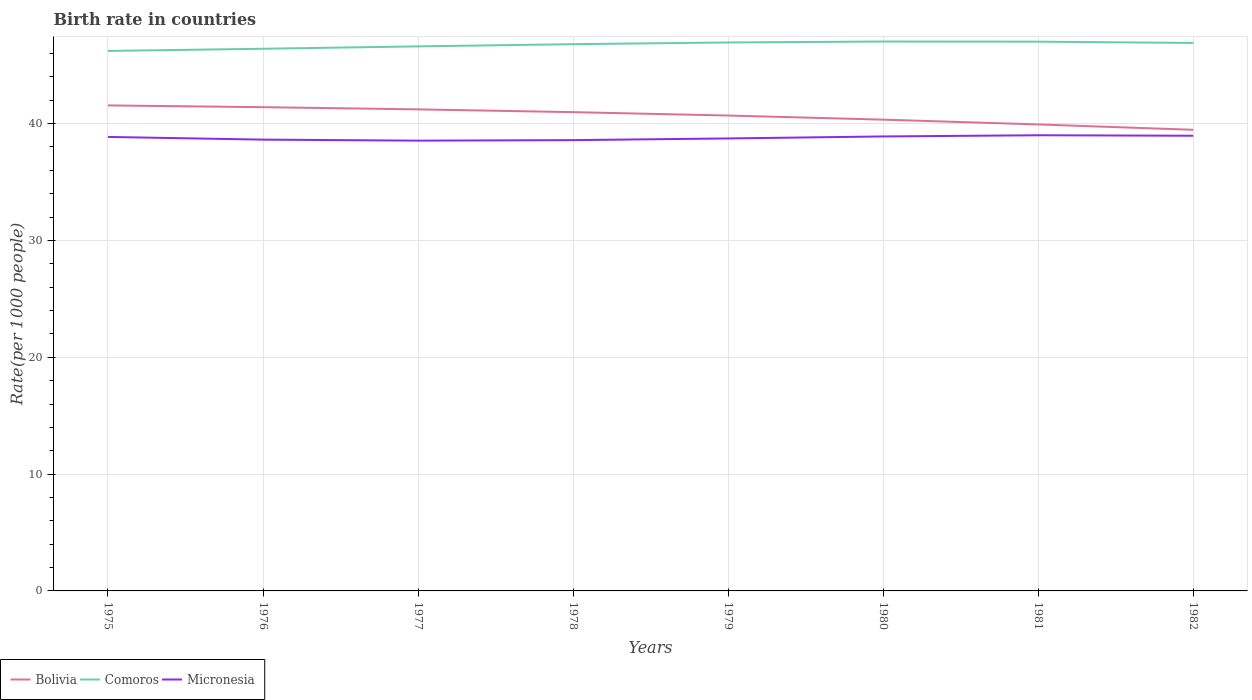Does the line corresponding to Bolivia intersect with the line corresponding to Comoros?
Make the answer very short. No. Is the number of lines equal to the number of legend labels?
Offer a very short reply. Yes. Across all years, what is the maximum birth rate in Micronesia?
Your response must be concise. 38.54. In which year was the birth rate in Bolivia maximum?
Your answer should be very brief. 1982. What is the total birth rate in Bolivia in the graph?
Give a very brief answer. 0.53. What is the difference between the highest and the second highest birth rate in Comoros?
Provide a short and direct response. 0.8. Are the values on the major ticks of Y-axis written in scientific E-notation?
Your answer should be compact. No. Where does the legend appear in the graph?
Offer a terse response. Bottom left. What is the title of the graph?
Offer a terse response. Birth rate in countries. What is the label or title of the X-axis?
Your response must be concise. Years. What is the label or title of the Y-axis?
Keep it short and to the point. Rate(per 1000 people). What is the Rate(per 1000 people) in Bolivia in 1975?
Provide a short and direct response. 41.56. What is the Rate(per 1000 people) in Comoros in 1975?
Provide a succinct answer. 46.22. What is the Rate(per 1000 people) of Micronesia in 1975?
Ensure brevity in your answer.  38.86. What is the Rate(per 1000 people) of Bolivia in 1976?
Make the answer very short. 41.41. What is the Rate(per 1000 people) of Comoros in 1976?
Offer a terse response. 46.41. What is the Rate(per 1000 people) in Micronesia in 1976?
Provide a succinct answer. 38.63. What is the Rate(per 1000 people) of Bolivia in 1977?
Keep it short and to the point. 41.22. What is the Rate(per 1000 people) in Comoros in 1977?
Your response must be concise. 46.61. What is the Rate(per 1000 people) of Micronesia in 1977?
Your answer should be compact. 38.54. What is the Rate(per 1000 people) of Bolivia in 1978?
Keep it short and to the point. 40.98. What is the Rate(per 1000 people) of Comoros in 1978?
Your answer should be very brief. 46.8. What is the Rate(per 1000 people) in Micronesia in 1978?
Make the answer very short. 38.59. What is the Rate(per 1000 people) in Bolivia in 1979?
Your response must be concise. 40.69. What is the Rate(per 1000 people) of Comoros in 1979?
Your answer should be compact. 46.95. What is the Rate(per 1000 people) of Micronesia in 1979?
Make the answer very short. 38.73. What is the Rate(per 1000 people) in Bolivia in 1980?
Provide a short and direct response. 40.34. What is the Rate(per 1000 people) of Comoros in 1980?
Make the answer very short. 47.03. What is the Rate(per 1000 people) in Micronesia in 1980?
Make the answer very short. 38.9. What is the Rate(per 1000 people) in Bolivia in 1981?
Your answer should be very brief. 39.93. What is the Rate(per 1000 people) of Comoros in 1981?
Offer a terse response. 47.02. What is the Rate(per 1000 people) of Micronesia in 1981?
Your answer should be compact. 39.01. What is the Rate(per 1000 people) of Bolivia in 1982?
Offer a very short reply. 39.47. What is the Rate(per 1000 people) in Comoros in 1982?
Your answer should be very brief. 46.91. What is the Rate(per 1000 people) of Micronesia in 1982?
Your response must be concise. 38.96. Across all years, what is the maximum Rate(per 1000 people) of Bolivia?
Make the answer very short. 41.56. Across all years, what is the maximum Rate(per 1000 people) in Comoros?
Make the answer very short. 47.03. Across all years, what is the maximum Rate(per 1000 people) of Micronesia?
Offer a terse response. 39.01. Across all years, what is the minimum Rate(per 1000 people) in Bolivia?
Your answer should be very brief. 39.47. Across all years, what is the minimum Rate(per 1000 people) in Comoros?
Your answer should be compact. 46.22. Across all years, what is the minimum Rate(per 1000 people) of Micronesia?
Your answer should be compact. 38.54. What is the total Rate(per 1000 people) in Bolivia in the graph?
Offer a terse response. 325.61. What is the total Rate(per 1000 people) of Comoros in the graph?
Keep it short and to the point. 373.94. What is the total Rate(per 1000 people) in Micronesia in the graph?
Offer a very short reply. 310.22. What is the difference between the Rate(per 1000 people) of Bolivia in 1975 and that in 1976?
Offer a very short reply. 0.15. What is the difference between the Rate(per 1000 people) of Comoros in 1975 and that in 1976?
Give a very brief answer. -0.19. What is the difference between the Rate(per 1000 people) of Micronesia in 1975 and that in 1976?
Ensure brevity in your answer.  0.23. What is the difference between the Rate(per 1000 people) of Bolivia in 1975 and that in 1977?
Keep it short and to the point. 0.34. What is the difference between the Rate(per 1000 people) of Comoros in 1975 and that in 1977?
Keep it short and to the point. -0.39. What is the difference between the Rate(per 1000 people) in Micronesia in 1975 and that in 1977?
Offer a terse response. 0.32. What is the difference between the Rate(per 1000 people) of Bolivia in 1975 and that in 1978?
Give a very brief answer. 0.58. What is the difference between the Rate(per 1000 people) in Comoros in 1975 and that in 1978?
Make the answer very short. -0.58. What is the difference between the Rate(per 1000 people) of Micronesia in 1975 and that in 1978?
Your answer should be compact. 0.27. What is the difference between the Rate(per 1000 people) in Bolivia in 1975 and that in 1979?
Ensure brevity in your answer.  0.87. What is the difference between the Rate(per 1000 people) in Comoros in 1975 and that in 1979?
Ensure brevity in your answer.  -0.73. What is the difference between the Rate(per 1000 people) in Micronesia in 1975 and that in 1979?
Give a very brief answer. 0.13. What is the difference between the Rate(per 1000 people) in Bolivia in 1975 and that in 1980?
Keep it short and to the point. 1.22. What is the difference between the Rate(per 1000 people) of Comoros in 1975 and that in 1980?
Provide a short and direct response. -0.81. What is the difference between the Rate(per 1000 people) in Micronesia in 1975 and that in 1980?
Provide a succinct answer. -0.04. What is the difference between the Rate(per 1000 people) of Bolivia in 1975 and that in 1981?
Ensure brevity in your answer.  1.63. What is the difference between the Rate(per 1000 people) of Comoros in 1975 and that in 1981?
Provide a short and direct response. -0.79. What is the difference between the Rate(per 1000 people) in Micronesia in 1975 and that in 1981?
Provide a short and direct response. -0.14. What is the difference between the Rate(per 1000 people) in Bolivia in 1975 and that in 1982?
Keep it short and to the point. 2.09. What is the difference between the Rate(per 1000 people) in Comoros in 1975 and that in 1982?
Your response must be concise. -0.68. What is the difference between the Rate(per 1000 people) in Micronesia in 1975 and that in 1982?
Give a very brief answer. -0.1. What is the difference between the Rate(per 1000 people) of Bolivia in 1976 and that in 1977?
Provide a short and direct response. 0.19. What is the difference between the Rate(per 1000 people) in Comoros in 1976 and that in 1977?
Make the answer very short. -0.2. What is the difference between the Rate(per 1000 people) in Micronesia in 1976 and that in 1977?
Your answer should be very brief. 0.09. What is the difference between the Rate(per 1000 people) of Bolivia in 1976 and that in 1978?
Offer a very short reply. 0.42. What is the difference between the Rate(per 1000 people) in Comoros in 1976 and that in 1978?
Your answer should be very brief. -0.39. What is the difference between the Rate(per 1000 people) of Micronesia in 1976 and that in 1978?
Your answer should be compact. 0.04. What is the difference between the Rate(per 1000 people) of Bolivia in 1976 and that in 1979?
Your response must be concise. 0.72. What is the difference between the Rate(per 1000 people) in Comoros in 1976 and that in 1979?
Your response must be concise. -0.54. What is the difference between the Rate(per 1000 people) of Micronesia in 1976 and that in 1979?
Give a very brief answer. -0.1. What is the difference between the Rate(per 1000 people) in Bolivia in 1976 and that in 1980?
Provide a short and direct response. 1.07. What is the difference between the Rate(per 1000 people) in Comoros in 1976 and that in 1980?
Offer a very short reply. -0.62. What is the difference between the Rate(per 1000 people) in Micronesia in 1976 and that in 1980?
Your answer should be very brief. -0.27. What is the difference between the Rate(per 1000 people) in Bolivia in 1976 and that in 1981?
Offer a terse response. 1.48. What is the difference between the Rate(per 1000 people) of Comoros in 1976 and that in 1981?
Offer a very short reply. -0.61. What is the difference between the Rate(per 1000 people) of Micronesia in 1976 and that in 1981?
Offer a terse response. -0.38. What is the difference between the Rate(per 1000 people) of Bolivia in 1976 and that in 1982?
Your response must be concise. 1.94. What is the difference between the Rate(per 1000 people) of Comoros in 1976 and that in 1982?
Keep it short and to the point. -0.5. What is the difference between the Rate(per 1000 people) in Micronesia in 1976 and that in 1982?
Offer a very short reply. -0.33. What is the difference between the Rate(per 1000 people) of Bolivia in 1977 and that in 1978?
Offer a terse response. 0.24. What is the difference between the Rate(per 1000 people) in Comoros in 1977 and that in 1978?
Your response must be concise. -0.19. What is the difference between the Rate(per 1000 people) in Micronesia in 1977 and that in 1978?
Provide a succinct answer. -0.04. What is the difference between the Rate(per 1000 people) of Bolivia in 1977 and that in 1979?
Make the answer very short. 0.53. What is the difference between the Rate(per 1000 people) in Comoros in 1977 and that in 1979?
Ensure brevity in your answer.  -0.34. What is the difference between the Rate(per 1000 people) of Micronesia in 1977 and that in 1979?
Your answer should be compact. -0.19. What is the difference between the Rate(per 1000 people) of Bolivia in 1977 and that in 1980?
Provide a succinct answer. 0.88. What is the difference between the Rate(per 1000 people) of Comoros in 1977 and that in 1980?
Provide a short and direct response. -0.41. What is the difference between the Rate(per 1000 people) in Micronesia in 1977 and that in 1980?
Your response must be concise. -0.36. What is the difference between the Rate(per 1000 people) in Bolivia in 1977 and that in 1981?
Make the answer very short. 1.29. What is the difference between the Rate(per 1000 people) in Comoros in 1977 and that in 1981?
Your answer should be compact. -0.4. What is the difference between the Rate(per 1000 people) of Micronesia in 1977 and that in 1981?
Offer a terse response. -0.46. What is the difference between the Rate(per 1000 people) in Bolivia in 1977 and that in 1982?
Provide a short and direct response. 1.75. What is the difference between the Rate(per 1000 people) of Comoros in 1977 and that in 1982?
Your response must be concise. -0.29. What is the difference between the Rate(per 1000 people) in Micronesia in 1977 and that in 1982?
Provide a succinct answer. -0.42. What is the difference between the Rate(per 1000 people) of Bolivia in 1978 and that in 1979?
Give a very brief answer. 0.29. What is the difference between the Rate(per 1000 people) of Comoros in 1978 and that in 1979?
Offer a very short reply. -0.15. What is the difference between the Rate(per 1000 people) in Micronesia in 1978 and that in 1979?
Your answer should be very brief. -0.14. What is the difference between the Rate(per 1000 people) of Bolivia in 1978 and that in 1980?
Give a very brief answer. 0.64. What is the difference between the Rate(per 1000 people) of Comoros in 1978 and that in 1980?
Provide a succinct answer. -0.23. What is the difference between the Rate(per 1000 people) of Micronesia in 1978 and that in 1980?
Provide a short and direct response. -0.31. What is the difference between the Rate(per 1000 people) in Bolivia in 1978 and that in 1981?
Make the answer very short. 1.05. What is the difference between the Rate(per 1000 people) in Comoros in 1978 and that in 1981?
Give a very brief answer. -0.21. What is the difference between the Rate(per 1000 people) of Micronesia in 1978 and that in 1981?
Keep it short and to the point. -0.42. What is the difference between the Rate(per 1000 people) of Bolivia in 1978 and that in 1982?
Your answer should be compact. 1.51. What is the difference between the Rate(per 1000 people) in Comoros in 1978 and that in 1982?
Your response must be concise. -0.11. What is the difference between the Rate(per 1000 people) of Micronesia in 1978 and that in 1982?
Your answer should be compact. -0.38. What is the difference between the Rate(per 1000 people) in Bolivia in 1979 and that in 1980?
Your answer should be compact. 0.35. What is the difference between the Rate(per 1000 people) in Comoros in 1979 and that in 1980?
Offer a terse response. -0.08. What is the difference between the Rate(per 1000 people) in Micronesia in 1979 and that in 1980?
Give a very brief answer. -0.17. What is the difference between the Rate(per 1000 people) of Bolivia in 1979 and that in 1981?
Keep it short and to the point. 0.76. What is the difference between the Rate(per 1000 people) of Comoros in 1979 and that in 1981?
Provide a succinct answer. -0.07. What is the difference between the Rate(per 1000 people) of Micronesia in 1979 and that in 1981?
Ensure brevity in your answer.  -0.27. What is the difference between the Rate(per 1000 people) in Bolivia in 1979 and that in 1982?
Your answer should be compact. 1.22. What is the difference between the Rate(per 1000 people) in Comoros in 1979 and that in 1982?
Ensure brevity in your answer.  0.04. What is the difference between the Rate(per 1000 people) of Micronesia in 1979 and that in 1982?
Provide a short and direct response. -0.23. What is the difference between the Rate(per 1000 people) of Bolivia in 1980 and that in 1981?
Your response must be concise. 0.41. What is the difference between the Rate(per 1000 people) of Comoros in 1980 and that in 1981?
Offer a terse response. 0.01. What is the difference between the Rate(per 1000 people) in Micronesia in 1980 and that in 1981?
Your response must be concise. -0.1. What is the difference between the Rate(per 1000 people) of Bolivia in 1980 and that in 1982?
Provide a succinct answer. 0.87. What is the difference between the Rate(per 1000 people) of Comoros in 1980 and that in 1982?
Provide a succinct answer. 0.12. What is the difference between the Rate(per 1000 people) in Micronesia in 1980 and that in 1982?
Ensure brevity in your answer.  -0.06. What is the difference between the Rate(per 1000 people) in Bolivia in 1981 and that in 1982?
Provide a succinct answer. 0.46. What is the difference between the Rate(per 1000 people) of Comoros in 1981 and that in 1982?
Ensure brevity in your answer.  0.11. What is the difference between the Rate(per 1000 people) of Micronesia in 1981 and that in 1982?
Keep it short and to the point. 0.04. What is the difference between the Rate(per 1000 people) of Bolivia in 1975 and the Rate(per 1000 people) of Comoros in 1976?
Your answer should be compact. -4.85. What is the difference between the Rate(per 1000 people) in Bolivia in 1975 and the Rate(per 1000 people) in Micronesia in 1976?
Keep it short and to the point. 2.93. What is the difference between the Rate(per 1000 people) of Comoros in 1975 and the Rate(per 1000 people) of Micronesia in 1976?
Provide a short and direct response. 7.59. What is the difference between the Rate(per 1000 people) in Bolivia in 1975 and the Rate(per 1000 people) in Comoros in 1977?
Offer a terse response. -5.05. What is the difference between the Rate(per 1000 people) in Bolivia in 1975 and the Rate(per 1000 people) in Micronesia in 1977?
Your answer should be compact. 3.02. What is the difference between the Rate(per 1000 people) in Comoros in 1975 and the Rate(per 1000 people) in Micronesia in 1977?
Offer a very short reply. 7.68. What is the difference between the Rate(per 1000 people) in Bolivia in 1975 and the Rate(per 1000 people) in Comoros in 1978?
Your answer should be very brief. -5.24. What is the difference between the Rate(per 1000 people) in Bolivia in 1975 and the Rate(per 1000 people) in Micronesia in 1978?
Give a very brief answer. 2.97. What is the difference between the Rate(per 1000 people) of Comoros in 1975 and the Rate(per 1000 people) of Micronesia in 1978?
Your answer should be very brief. 7.63. What is the difference between the Rate(per 1000 people) in Bolivia in 1975 and the Rate(per 1000 people) in Comoros in 1979?
Your answer should be compact. -5.39. What is the difference between the Rate(per 1000 people) in Bolivia in 1975 and the Rate(per 1000 people) in Micronesia in 1979?
Ensure brevity in your answer.  2.83. What is the difference between the Rate(per 1000 people) of Comoros in 1975 and the Rate(per 1000 people) of Micronesia in 1979?
Make the answer very short. 7.49. What is the difference between the Rate(per 1000 people) of Bolivia in 1975 and the Rate(per 1000 people) of Comoros in 1980?
Make the answer very short. -5.47. What is the difference between the Rate(per 1000 people) in Bolivia in 1975 and the Rate(per 1000 people) in Micronesia in 1980?
Your answer should be very brief. 2.66. What is the difference between the Rate(per 1000 people) of Comoros in 1975 and the Rate(per 1000 people) of Micronesia in 1980?
Provide a succinct answer. 7.32. What is the difference between the Rate(per 1000 people) of Bolivia in 1975 and the Rate(per 1000 people) of Comoros in 1981?
Provide a succinct answer. -5.46. What is the difference between the Rate(per 1000 people) of Bolivia in 1975 and the Rate(per 1000 people) of Micronesia in 1981?
Your answer should be very brief. 2.56. What is the difference between the Rate(per 1000 people) of Comoros in 1975 and the Rate(per 1000 people) of Micronesia in 1981?
Your answer should be very brief. 7.22. What is the difference between the Rate(per 1000 people) in Bolivia in 1975 and the Rate(per 1000 people) in Comoros in 1982?
Offer a very short reply. -5.35. What is the difference between the Rate(per 1000 people) of Bolivia in 1975 and the Rate(per 1000 people) of Micronesia in 1982?
Give a very brief answer. 2.6. What is the difference between the Rate(per 1000 people) in Comoros in 1975 and the Rate(per 1000 people) in Micronesia in 1982?
Provide a succinct answer. 7.26. What is the difference between the Rate(per 1000 people) in Bolivia in 1976 and the Rate(per 1000 people) in Comoros in 1977?
Offer a terse response. -5.2. What is the difference between the Rate(per 1000 people) of Bolivia in 1976 and the Rate(per 1000 people) of Micronesia in 1977?
Your answer should be compact. 2.87. What is the difference between the Rate(per 1000 people) of Comoros in 1976 and the Rate(per 1000 people) of Micronesia in 1977?
Provide a succinct answer. 7.87. What is the difference between the Rate(per 1000 people) in Bolivia in 1976 and the Rate(per 1000 people) in Comoros in 1978?
Keep it short and to the point. -5.39. What is the difference between the Rate(per 1000 people) of Bolivia in 1976 and the Rate(per 1000 people) of Micronesia in 1978?
Your answer should be compact. 2.82. What is the difference between the Rate(per 1000 people) in Comoros in 1976 and the Rate(per 1000 people) in Micronesia in 1978?
Offer a terse response. 7.82. What is the difference between the Rate(per 1000 people) in Bolivia in 1976 and the Rate(per 1000 people) in Comoros in 1979?
Give a very brief answer. -5.54. What is the difference between the Rate(per 1000 people) in Bolivia in 1976 and the Rate(per 1000 people) in Micronesia in 1979?
Your response must be concise. 2.68. What is the difference between the Rate(per 1000 people) of Comoros in 1976 and the Rate(per 1000 people) of Micronesia in 1979?
Keep it short and to the point. 7.68. What is the difference between the Rate(per 1000 people) of Bolivia in 1976 and the Rate(per 1000 people) of Comoros in 1980?
Keep it short and to the point. -5.62. What is the difference between the Rate(per 1000 people) in Bolivia in 1976 and the Rate(per 1000 people) in Micronesia in 1980?
Offer a very short reply. 2.51. What is the difference between the Rate(per 1000 people) of Comoros in 1976 and the Rate(per 1000 people) of Micronesia in 1980?
Offer a terse response. 7.51. What is the difference between the Rate(per 1000 people) in Bolivia in 1976 and the Rate(per 1000 people) in Comoros in 1981?
Offer a very short reply. -5.61. What is the difference between the Rate(per 1000 people) of Bolivia in 1976 and the Rate(per 1000 people) of Micronesia in 1981?
Provide a short and direct response. 2.4. What is the difference between the Rate(per 1000 people) in Comoros in 1976 and the Rate(per 1000 people) in Micronesia in 1981?
Your response must be concise. 7.4. What is the difference between the Rate(per 1000 people) of Bolivia in 1976 and the Rate(per 1000 people) of Comoros in 1982?
Your answer should be very brief. -5.5. What is the difference between the Rate(per 1000 people) in Bolivia in 1976 and the Rate(per 1000 people) in Micronesia in 1982?
Give a very brief answer. 2.44. What is the difference between the Rate(per 1000 people) of Comoros in 1976 and the Rate(per 1000 people) of Micronesia in 1982?
Your response must be concise. 7.45. What is the difference between the Rate(per 1000 people) in Bolivia in 1977 and the Rate(per 1000 people) in Comoros in 1978?
Offer a terse response. -5.58. What is the difference between the Rate(per 1000 people) of Bolivia in 1977 and the Rate(per 1000 people) of Micronesia in 1978?
Your answer should be compact. 2.63. What is the difference between the Rate(per 1000 people) of Comoros in 1977 and the Rate(per 1000 people) of Micronesia in 1978?
Your answer should be compact. 8.02. What is the difference between the Rate(per 1000 people) of Bolivia in 1977 and the Rate(per 1000 people) of Comoros in 1979?
Ensure brevity in your answer.  -5.73. What is the difference between the Rate(per 1000 people) of Bolivia in 1977 and the Rate(per 1000 people) of Micronesia in 1979?
Provide a succinct answer. 2.49. What is the difference between the Rate(per 1000 people) in Comoros in 1977 and the Rate(per 1000 people) in Micronesia in 1979?
Ensure brevity in your answer.  7.88. What is the difference between the Rate(per 1000 people) in Bolivia in 1977 and the Rate(per 1000 people) in Comoros in 1980?
Provide a short and direct response. -5.81. What is the difference between the Rate(per 1000 people) of Bolivia in 1977 and the Rate(per 1000 people) of Micronesia in 1980?
Keep it short and to the point. 2.32. What is the difference between the Rate(per 1000 people) of Comoros in 1977 and the Rate(per 1000 people) of Micronesia in 1980?
Your answer should be very brief. 7.71. What is the difference between the Rate(per 1000 people) in Bolivia in 1977 and the Rate(per 1000 people) in Comoros in 1981?
Your answer should be compact. -5.8. What is the difference between the Rate(per 1000 people) of Bolivia in 1977 and the Rate(per 1000 people) of Micronesia in 1981?
Your response must be concise. 2.21. What is the difference between the Rate(per 1000 people) in Comoros in 1977 and the Rate(per 1000 people) in Micronesia in 1981?
Make the answer very short. 7.61. What is the difference between the Rate(per 1000 people) of Bolivia in 1977 and the Rate(per 1000 people) of Comoros in 1982?
Your answer should be very brief. -5.69. What is the difference between the Rate(per 1000 people) in Bolivia in 1977 and the Rate(per 1000 people) in Micronesia in 1982?
Your answer should be compact. 2.26. What is the difference between the Rate(per 1000 people) in Comoros in 1977 and the Rate(per 1000 people) in Micronesia in 1982?
Your response must be concise. 7.65. What is the difference between the Rate(per 1000 people) in Bolivia in 1978 and the Rate(per 1000 people) in Comoros in 1979?
Offer a terse response. -5.96. What is the difference between the Rate(per 1000 people) of Bolivia in 1978 and the Rate(per 1000 people) of Micronesia in 1979?
Offer a very short reply. 2.25. What is the difference between the Rate(per 1000 people) in Comoros in 1978 and the Rate(per 1000 people) in Micronesia in 1979?
Offer a terse response. 8.07. What is the difference between the Rate(per 1000 people) in Bolivia in 1978 and the Rate(per 1000 people) in Comoros in 1980?
Your answer should be very brief. -6.04. What is the difference between the Rate(per 1000 people) in Bolivia in 1978 and the Rate(per 1000 people) in Micronesia in 1980?
Your answer should be very brief. 2.08. What is the difference between the Rate(per 1000 people) in Comoros in 1978 and the Rate(per 1000 people) in Micronesia in 1980?
Give a very brief answer. 7.9. What is the difference between the Rate(per 1000 people) of Bolivia in 1978 and the Rate(per 1000 people) of Comoros in 1981?
Keep it short and to the point. -6.03. What is the difference between the Rate(per 1000 people) in Bolivia in 1978 and the Rate(per 1000 people) in Micronesia in 1981?
Offer a terse response. 1.98. What is the difference between the Rate(per 1000 people) in Comoros in 1978 and the Rate(per 1000 people) in Micronesia in 1981?
Ensure brevity in your answer.  7.79. What is the difference between the Rate(per 1000 people) of Bolivia in 1978 and the Rate(per 1000 people) of Comoros in 1982?
Your answer should be compact. -5.92. What is the difference between the Rate(per 1000 people) in Bolivia in 1978 and the Rate(per 1000 people) in Micronesia in 1982?
Provide a succinct answer. 2.02. What is the difference between the Rate(per 1000 people) in Comoros in 1978 and the Rate(per 1000 people) in Micronesia in 1982?
Keep it short and to the point. 7.84. What is the difference between the Rate(per 1000 people) of Bolivia in 1979 and the Rate(per 1000 people) of Comoros in 1980?
Your answer should be compact. -6.33. What is the difference between the Rate(per 1000 people) in Bolivia in 1979 and the Rate(per 1000 people) in Micronesia in 1980?
Your answer should be compact. 1.79. What is the difference between the Rate(per 1000 people) of Comoros in 1979 and the Rate(per 1000 people) of Micronesia in 1980?
Offer a very short reply. 8.05. What is the difference between the Rate(per 1000 people) in Bolivia in 1979 and the Rate(per 1000 people) in Comoros in 1981?
Your answer should be very brief. -6.32. What is the difference between the Rate(per 1000 people) of Bolivia in 1979 and the Rate(per 1000 people) of Micronesia in 1981?
Your response must be concise. 1.69. What is the difference between the Rate(per 1000 people) of Comoros in 1979 and the Rate(per 1000 people) of Micronesia in 1981?
Your response must be concise. 7.94. What is the difference between the Rate(per 1000 people) of Bolivia in 1979 and the Rate(per 1000 people) of Comoros in 1982?
Offer a very short reply. -6.21. What is the difference between the Rate(per 1000 people) in Bolivia in 1979 and the Rate(per 1000 people) in Micronesia in 1982?
Make the answer very short. 1.73. What is the difference between the Rate(per 1000 people) in Comoros in 1979 and the Rate(per 1000 people) in Micronesia in 1982?
Provide a succinct answer. 7.99. What is the difference between the Rate(per 1000 people) in Bolivia in 1980 and the Rate(per 1000 people) in Comoros in 1981?
Your response must be concise. -6.67. What is the difference between the Rate(per 1000 people) in Bolivia in 1980 and the Rate(per 1000 people) in Micronesia in 1981?
Your response must be concise. 1.34. What is the difference between the Rate(per 1000 people) of Comoros in 1980 and the Rate(per 1000 people) of Micronesia in 1981?
Offer a terse response. 8.02. What is the difference between the Rate(per 1000 people) of Bolivia in 1980 and the Rate(per 1000 people) of Comoros in 1982?
Make the answer very short. -6.57. What is the difference between the Rate(per 1000 people) of Bolivia in 1980 and the Rate(per 1000 people) of Micronesia in 1982?
Give a very brief answer. 1.38. What is the difference between the Rate(per 1000 people) in Comoros in 1980 and the Rate(per 1000 people) in Micronesia in 1982?
Your response must be concise. 8.06. What is the difference between the Rate(per 1000 people) of Bolivia in 1981 and the Rate(per 1000 people) of Comoros in 1982?
Keep it short and to the point. -6.97. What is the difference between the Rate(per 1000 people) of Bolivia in 1981 and the Rate(per 1000 people) of Micronesia in 1982?
Your answer should be very brief. 0.97. What is the difference between the Rate(per 1000 people) of Comoros in 1981 and the Rate(per 1000 people) of Micronesia in 1982?
Your answer should be compact. 8.05. What is the average Rate(per 1000 people) of Bolivia per year?
Ensure brevity in your answer.  40.7. What is the average Rate(per 1000 people) of Comoros per year?
Ensure brevity in your answer.  46.74. What is the average Rate(per 1000 people) of Micronesia per year?
Keep it short and to the point. 38.78. In the year 1975, what is the difference between the Rate(per 1000 people) in Bolivia and Rate(per 1000 people) in Comoros?
Keep it short and to the point. -4.66. In the year 1975, what is the difference between the Rate(per 1000 people) in Bolivia and Rate(per 1000 people) in Micronesia?
Ensure brevity in your answer.  2.7. In the year 1975, what is the difference between the Rate(per 1000 people) in Comoros and Rate(per 1000 people) in Micronesia?
Offer a terse response. 7.36. In the year 1976, what is the difference between the Rate(per 1000 people) in Bolivia and Rate(per 1000 people) in Comoros?
Provide a short and direct response. -5. In the year 1976, what is the difference between the Rate(per 1000 people) in Bolivia and Rate(per 1000 people) in Micronesia?
Offer a terse response. 2.78. In the year 1976, what is the difference between the Rate(per 1000 people) of Comoros and Rate(per 1000 people) of Micronesia?
Your answer should be very brief. 7.78. In the year 1977, what is the difference between the Rate(per 1000 people) of Bolivia and Rate(per 1000 people) of Comoros?
Ensure brevity in your answer.  -5.39. In the year 1977, what is the difference between the Rate(per 1000 people) in Bolivia and Rate(per 1000 people) in Micronesia?
Make the answer very short. 2.68. In the year 1977, what is the difference between the Rate(per 1000 people) in Comoros and Rate(per 1000 people) in Micronesia?
Provide a succinct answer. 8.07. In the year 1978, what is the difference between the Rate(per 1000 people) in Bolivia and Rate(per 1000 people) in Comoros?
Your response must be concise. -5.82. In the year 1978, what is the difference between the Rate(per 1000 people) in Bolivia and Rate(per 1000 people) in Micronesia?
Provide a succinct answer. 2.4. In the year 1978, what is the difference between the Rate(per 1000 people) of Comoros and Rate(per 1000 people) of Micronesia?
Your response must be concise. 8.21. In the year 1979, what is the difference between the Rate(per 1000 people) of Bolivia and Rate(per 1000 people) of Comoros?
Offer a very short reply. -6.26. In the year 1979, what is the difference between the Rate(per 1000 people) of Bolivia and Rate(per 1000 people) of Micronesia?
Provide a succinct answer. 1.96. In the year 1979, what is the difference between the Rate(per 1000 people) of Comoros and Rate(per 1000 people) of Micronesia?
Ensure brevity in your answer.  8.22. In the year 1980, what is the difference between the Rate(per 1000 people) in Bolivia and Rate(per 1000 people) in Comoros?
Give a very brief answer. -6.69. In the year 1980, what is the difference between the Rate(per 1000 people) in Bolivia and Rate(per 1000 people) in Micronesia?
Provide a succinct answer. 1.44. In the year 1980, what is the difference between the Rate(per 1000 people) in Comoros and Rate(per 1000 people) in Micronesia?
Provide a short and direct response. 8.12. In the year 1981, what is the difference between the Rate(per 1000 people) in Bolivia and Rate(per 1000 people) in Comoros?
Your answer should be very brief. -7.08. In the year 1981, what is the difference between the Rate(per 1000 people) in Bolivia and Rate(per 1000 people) in Micronesia?
Your answer should be very brief. 0.93. In the year 1981, what is the difference between the Rate(per 1000 people) in Comoros and Rate(per 1000 people) in Micronesia?
Ensure brevity in your answer.  8.01. In the year 1982, what is the difference between the Rate(per 1000 people) in Bolivia and Rate(per 1000 people) in Comoros?
Make the answer very short. -7.43. In the year 1982, what is the difference between the Rate(per 1000 people) of Bolivia and Rate(per 1000 people) of Micronesia?
Provide a short and direct response. 0.51. In the year 1982, what is the difference between the Rate(per 1000 people) of Comoros and Rate(per 1000 people) of Micronesia?
Your answer should be compact. 7.94. What is the ratio of the Rate(per 1000 people) in Bolivia in 1975 to that in 1976?
Your answer should be compact. 1. What is the ratio of the Rate(per 1000 people) in Comoros in 1975 to that in 1976?
Offer a terse response. 1. What is the ratio of the Rate(per 1000 people) of Bolivia in 1975 to that in 1977?
Keep it short and to the point. 1.01. What is the ratio of the Rate(per 1000 people) of Micronesia in 1975 to that in 1977?
Provide a short and direct response. 1.01. What is the ratio of the Rate(per 1000 people) in Bolivia in 1975 to that in 1978?
Provide a short and direct response. 1.01. What is the ratio of the Rate(per 1000 people) of Comoros in 1975 to that in 1978?
Make the answer very short. 0.99. What is the ratio of the Rate(per 1000 people) of Micronesia in 1975 to that in 1978?
Your answer should be very brief. 1.01. What is the ratio of the Rate(per 1000 people) in Bolivia in 1975 to that in 1979?
Ensure brevity in your answer.  1.02. What is the ratio of the Rate(per 1000 people) in Comoros in 1975 to that in 1979?
Offer a very short reply. 0.98. What is the ratio of the Rate(per 1000 people) of Micronesia in 1975 to that in 1979?
Offer a terse response. 1. What is the ratio of the Rate(per 1000 people) of Bolivia in 1975 to that in 1980?
Your response must be concise. 1.03. What is the ratio of the Rate(per 1000 people) in Comoros in 1975 to that in 1980?
Keep it short and to the point. 0.98. What is the ratio of the Rate(per 1000 people) of Micronesia in 1975 to that in 1980?
Provide a succinct answer. 1. What is the ratio of the Rate(per 1000 people) in Bolivia in 1975 to that in 1981?
Ensure brevity in your answer.  1.04. What is the ratio of the Rate(per 1000 people) in Comoros in 1975 to that in 1981?
Make the answer very short. 0.98. What is the ratio of the Rate(per 1000 people) in Micronesia in 1975 to that in 1981?
Make the answer very short. 1. What is the ratio of the Rate(per 1000 people) in Bolivia in 1975 to that in 1982?
Offer a terse response. 1.05. What is the ratio of the Rate(per 1000 people) of Comoros in 1975 to that in 1982?
Make the answer very short. 0.99. What is the ratio of the Rate(per 1000 people) of Micronesia in 1975 to that in 1982?
Offer a terse response. 1. What is the ratio of the Rate(per 1000 people) in Bolivia in 1976 to that in 1977?
Your answer should be compact. 1. What is the ratio of the Rate(per 1000 people) in Bolivia in 1976 to that in 1978?
Your answer should be very brief. 1.01. What is the ratio of the Rate(per 1000 people) in Bolivia in 1976 to that in 1979?
Provide a succinct answer. 1.02. What is the ratio of the Rate(per 1000 people) of Bolivia in 1976 to that in 1980?
Make the answer very short. 1.03. What is the ratio of the Rate(per 1000 people) of Comoros in 1976 to that in 1980?
Make the answer very short. 0.99. What is the ratio of the Rate(per 1000 people) of Micronesia in 1976 to that in 1980?
Provide a short and direct response. 0.99. What is the ratio of the Rate(per 1000 people) of Comoros in 1976 to that in 1981?
Provide a short and direct response. 0.99. What is the ratio of the Rate(per 1000 people) in Micronesia in 1976 to that in 1981?
Make the answer very short. 0.99. What is the ratio of the Rate(per 1000 people) of Bolivia in 1976 to that in 1982?
Provide a short and direct response. 1.05. What is the ratio of the Rate(per 1000 people) of Comoros in 1976 to that in 1982?
Keep it short and to the point. 0.99. What is the ratio of the Rate(per 1000 people) in Micronesia in 1976 to that in 1982?
Make the answer very short. 0.99. What is the ratio of the Rate(per 1000 people) of Bolivia in 1977 to that in 1978?
Make the answer very short. 1.01. What is the ratio of the Rate(per 1000 people) in Micronesia in 1977 to that in 1978?
Your answer should be compact. 1. What is the ratio of the Rate(per 1000 people) in Bolivia in 1977 to that in 1980?
Offer a terse response. 1.02. What is the ratio of the Rate(per 1000 people) in Comoros in 1977 to that in 1980?
Keep it short and to the point. 0.99. What is the ratio of the Rate(per 1000 people) of Micronesia in 1977 to that in 1980?
Offer a very short reply. 0.99. What is the ratio of the Rate(per 1000 people) in Bolivia in 1977 to that in 1981?
Your answer should be compact. 1.03. What is the ratio of the Rate(per 1000 people) of Comoros in 1977 to that in 1981?
Provide a succinct answer. 0.99. What is the ratio of the Rate(per 1000 people) in Bolivia in 1977 to that in 1982?
Your answer should be very brief. 1.04. What is the ratio of the Rate(per 1000 people) of Comoros in 1977 to that in 1982?
Give a very brief answer. 0.99. What is the ratio of the Rate(per 1000 people) in Bolivia in 1978 to that in 1980?
Your answer should be very brief. 1.02. What is the ratio of the Rate(per 1000 people) in Comoros in 1978 to that in 1980?
Your response must be concise. 1. What is the ratio of the Rate(per 1000 people) in Micronesia in 1978 to that in 1980?
Your answer should be very brief. 0.99. What is the ratio of the Rate(per 1000 people) in Bolivia in 1978 to that in 1981?
Offer a very short reply. 1.03. What is the ratio of the Rate(per 1000 people) of Comoros in 1978 to that in 1981?
Provide a succinct answer. 1. What is the ratio of the Rate(per 1000 people) in Micronesia in 1978 to that in 1981?
Provide a succinct answer. 0.99. What is the ratio of the Rate(per 1000 people) of Bolivia in 1978 to that in 1982?
Your answer should be very brief. 1.04. What is the ratio of the Rate(per 1000 people) of Comoros in 1978 to that in 1982?
Your response must be concise. 1. What is the ratio of the Rate(per 1000 people) of Bolivia in 1979 to that in 1980?
Your answer should be compact. 1.01. What is the ratio of the Rate(per 1000 people) of Comoros in 1979 to that in 1980?
Ensure brevity in your answer.  1. What is the ratio of the Rate(per 1000 people) of Micronesia in 1979 to that in 1980?
Ensure brevity in your answer.  1. What is the ratio of the Rate(per 1000 people) of Bolivia in 1979 to that in 1981?
Make the answer very short. 1.02. What is the ratio of the Rate(per 1000 people) in Comoros in 1979 to that in 1981?
Give a very brief answer. 1. What is the ratio of the Rate(per 1000 people) in Bolivia in 1979 to that in 1982?
Offer a very short reply. 1.03. What is the ratio of the Rate(per 1000 people) of Bolivia in 1980 to that in 1981?
Offer a terse response. 1.01. What is the ratio of the Rate(per 1000 people) of Micronesia in 1980 to that in 1981?
Your answer should be compact. 1. What is the ratio of the Rate(per 1000 people) of Micronesia in 1980 to that in 1982?
Make the answer very short. 1. What is the ratio of the Rate(per 1000 people) in Bolivia in 1981 to that in 1982?
Provide a succinct answer. 1.01. What is the ratio of the Rate(per 1000 people) in Micronesia in 1981 to that in 1982?
Offer a terse response. 1. What is the difference between the highest and the second highest Rate(per 1000 people) of Bolivia?
Give a very brief answer. 0.15. What is the difference between the highest and the second highest Rate(per 1000 people) in Comoros?
Your response must be concise. 0.01. What is the difference between the highest and the second highest Rate(per 1000 people) in Micronesia?
Your response must be concise. 0.04. What is the difference between the highest and the lowest Rate(per 1000 people) in Bolivia?
Provide a short and direct response. 2.09. What is the difference between the highest and the lowest Rate(per 1000 people) in Comoros?
Ensure brevity in your answer.  0.81. What is the difference between the highest and the lowest Rate(per 1000 people) of Micronesia?
Your answer should be very brief. 0.46. 